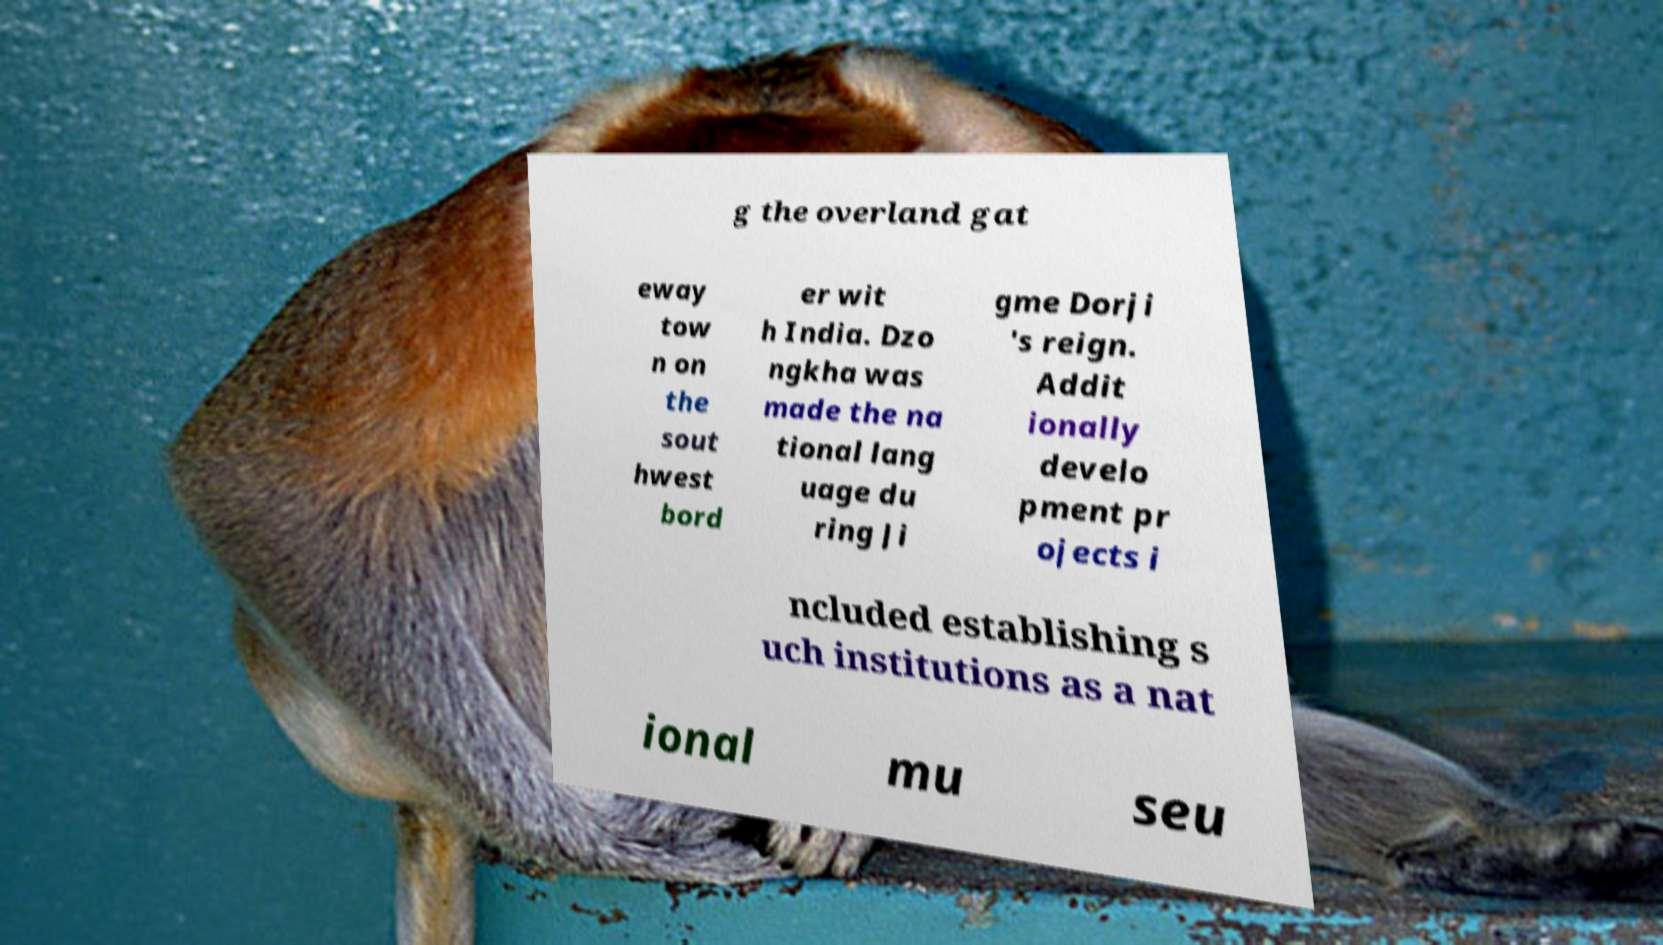Could you extract and type out the text from this image? g the overland gat eway tow n on the sout hwest bord er wit h India. Dzo ngkha was made the na tional lang uage du ring Ji gme Dorji 's reign. Addit ionally develo pment pr ojects i ncluded establishing s uch institutions as a nat ional mu seu 